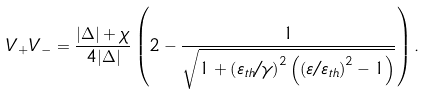<formula> <loc_0><loc_0><loc_500><loc_500>V _ { + } V _ { - } = \frac { | \Delta | + \chi } { 4 | \Delta | } \left ( 2 - \frac { 1 } { \sqrt { 1 + \left ( \varepsilon _ { t h } / \gamma \right ) ^ { 2 } \left ( \left ( \varepsilon / \varepsilon _ { t h } \right ) ^ { 2 } - 1 \right ) } } \right ) .</formula> 